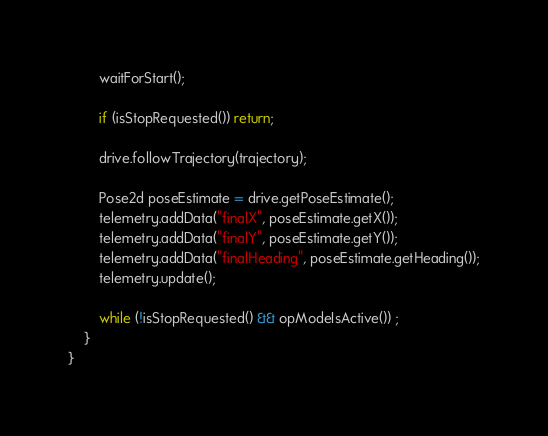Convert code to text. <code><loc_0><loc_0><loc_500><loc_500><_Java_>        waitForStart();

        if (isStopRequested()) return;

        drive.followTrajectory(trajectory);

        Pose2d poseEstimate = drive.getPoseEstimate();
        telemetry.addData("finalX", poseEstimate.getX());
        telemetry.addData("finalY", poseEstimate.getY());
        telemetry.addData("finalHeading", poseEstimate.getHeading());
        telemetry.update();

        while (!isStopRequested() && opModeIsActive()) ;
    }
}
</code> 